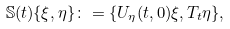<formula> <loc_0><loc_0><loc_500><loc_500>\mathbb { S } ( t ) \{ \xi , \eta \} \colon = \{ U _ { \eta } ( t , 0 ) \xi , T _ { t } \eta \} ,</formula> 